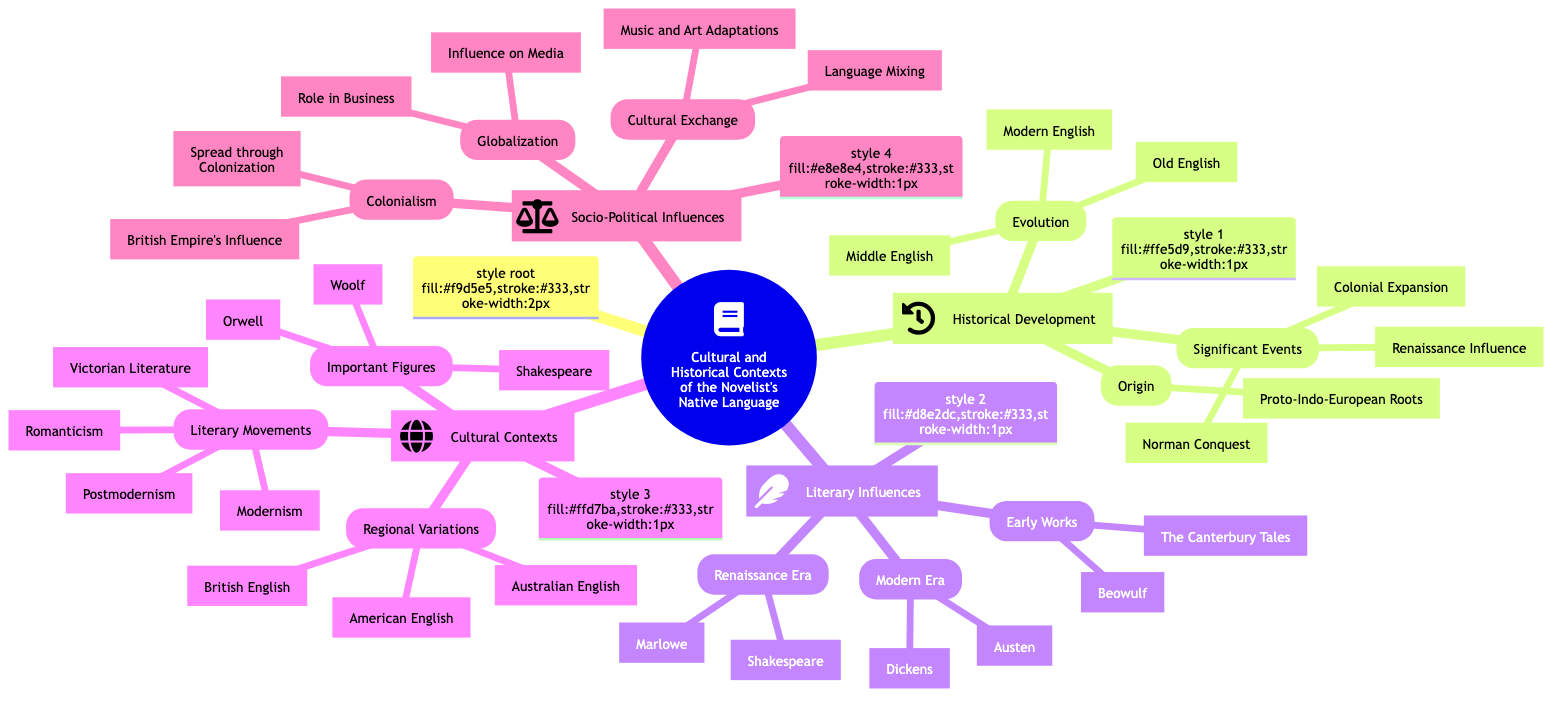What is the central topic of the Mind Map? The central topic is clearly labeled in the diagram as "Cultural and Historical Contexts of the Novelist's Native Language."
Answer: Cultural and Historical Contexts of the Novelist's Native Language How many main subtopics are there in the Mind Map? There are four main subtopics branching from the central topic: Historical Development, Literary Influences, Cultural Contexts, and Socio-Political Influences.
Answer: 4 What is one literary work from the Early Works section? The Early Works section lists "Beowulf" as one of the works.
Answer: Beowulf What significant event is associated with the year 1066? The Norman Conquest is categorized as a significant event which occurred in 1066.
Answer: Norman Conquest Which literary movement follows Victorian Literature? The literary movement that follows Victorian Literature is Modernism, as presented in the order of the Literary Movements subtopic.
Answer: Modernism Who are two important figures listed in the Cultural Contexts section? The Cultural Contexts section highlights several important figures, including William Shakespeare and Virginia Woolf.
Answer: William Shakespeare, Virginia Woolf What is one impact of Colonialism mentioned in the diagram? The diagram states that the British Empire's Global Influence is an impact of Colonialism.
Answer: British Empire's Global Influence Which two regional variations of English are mentioned in the Mind Map? The Mind Map lists British English and American English as two of the regional variations.
Answer: British English, American English What era contains the works of Christopher Marlowe? The Renaissance Era is where Christopher Marlowe's works are categorized within the Literary Influences subtopic.
Answer: Renaissance Era 